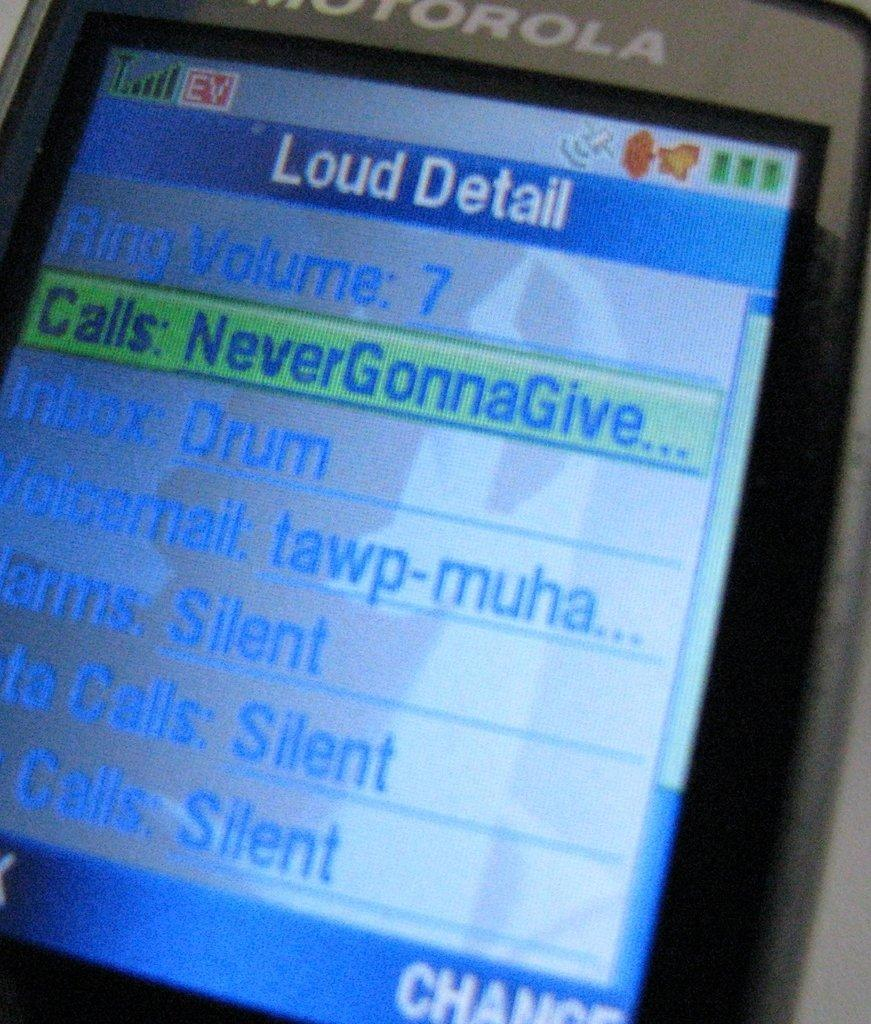<image>
Summarize the visual content of the image. a picture of a phone screen looking at ringer volume and ringer sounds. 